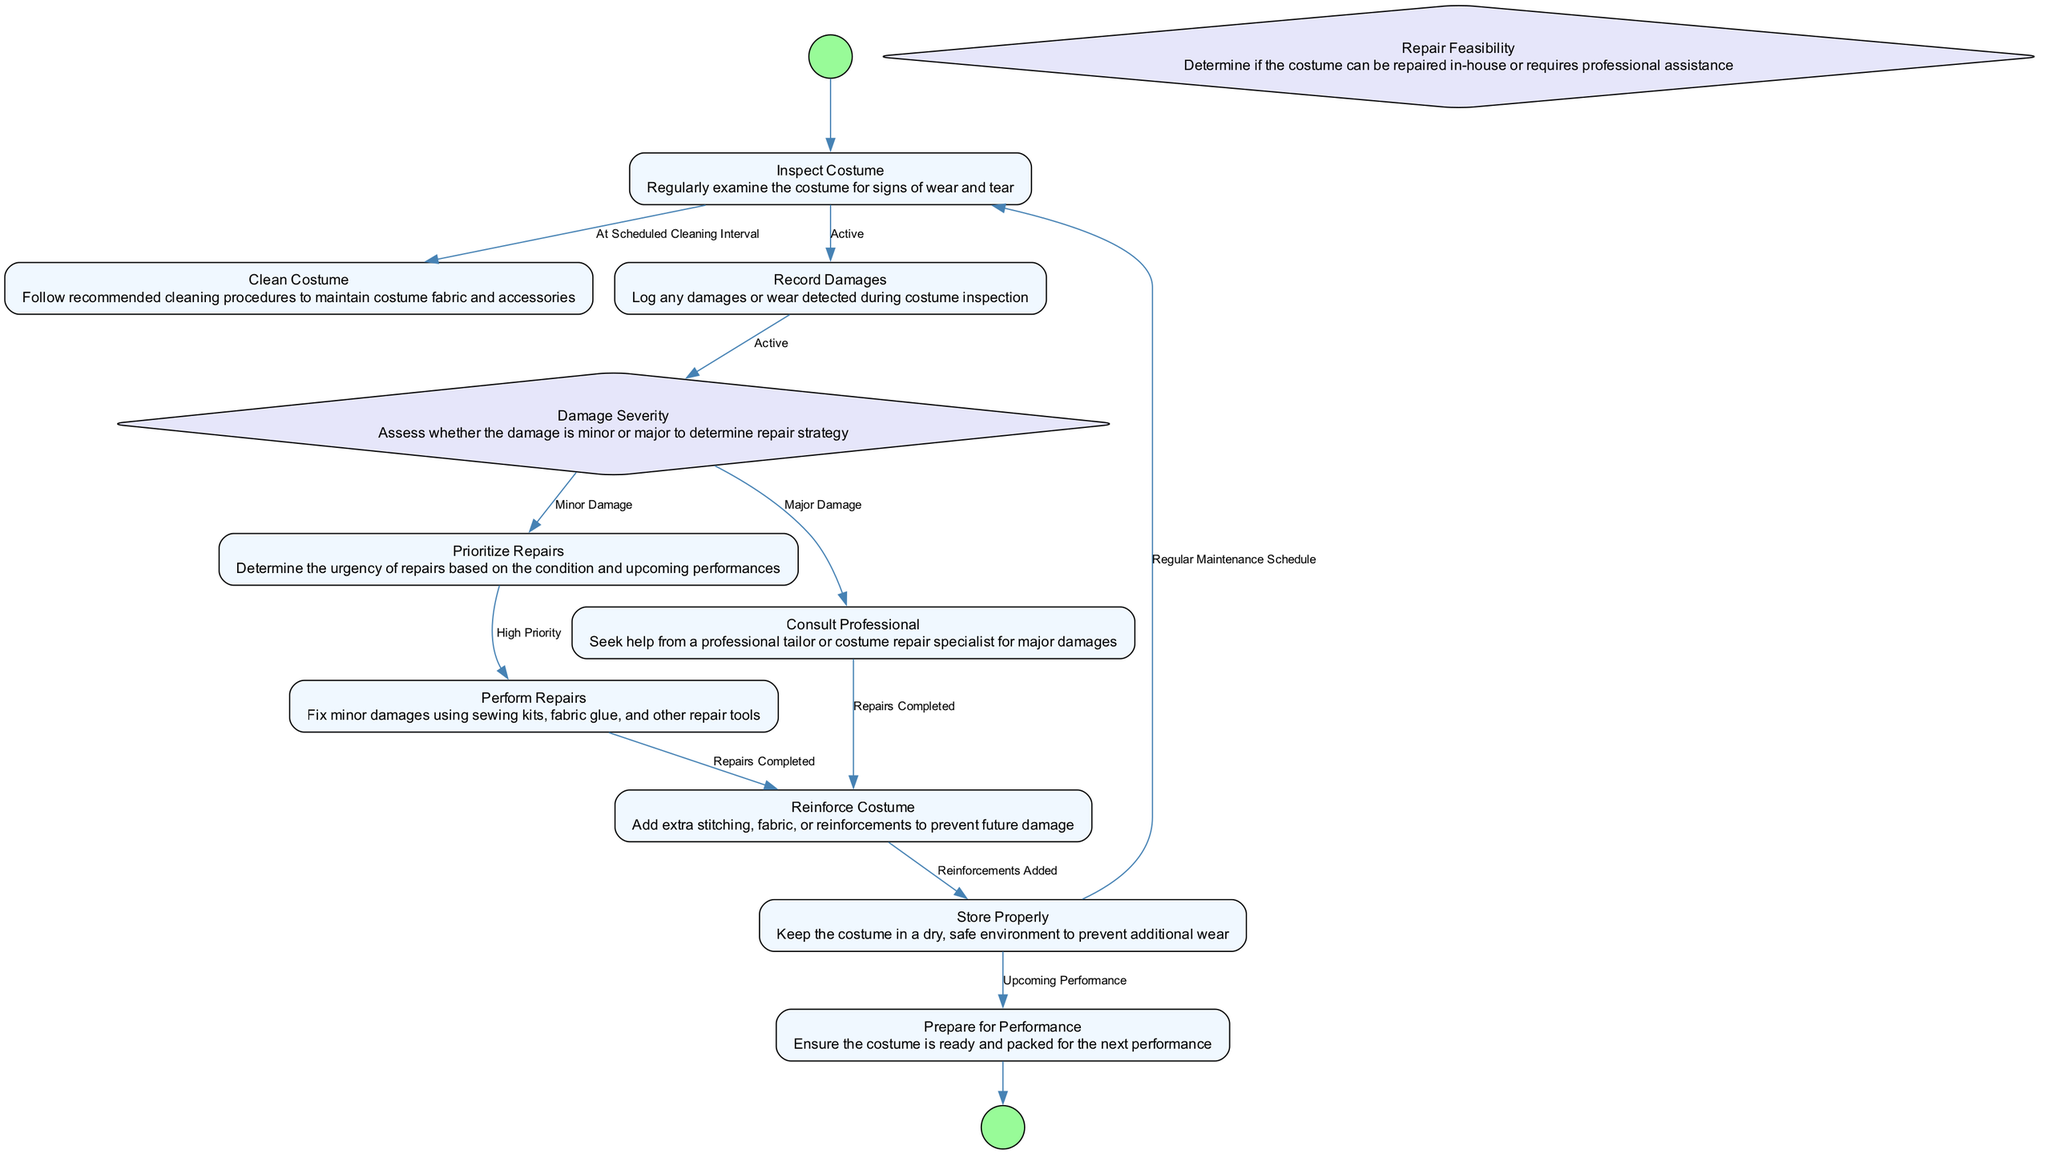What is the first action in the diagram? The first action is represented by the initial node connected to the start node, which is "Inspect Costume."
Answer: Inspect Costume How many actions are there in total? The diagram lists eight actions that are depicted as rectangular nodes. Counting all the action nodes gives a total of eight.
Answer: 8 What is the condition that leads from "Record Damages" to "Damage Severity"? The diagram shows an edge from "Record Damages" to "Damage Severity" that is labeled with the condition "Active." This indicates that the transition occurs when there are active records of damages.
Answer: Active What happens if the damage is classified as "Major Damage"? Following the decision node "Damage Severity" leads to "Consult Professional" for major damage, which indicates that action is required from a professional for repairs.
Answer: Consult Professional What action is performed after "Perform Repairs" if the repairs are completed? Once the repairs are completed, the flow goes to the next action, which is "Reinforce Costume." This indicates that reinforcement actions follow the completion of repairs.
Answer: Reinforce Costume How is "Store Properly" connected to both "Inspect Costume" and "Prepare for Performance"? "Store Properly" has two outgoing edges, one leading back to "Inspect Costume" based on a regular maintenance schedule, and another directed to "Prepare for Performance" for upcoming performances, indicating its dual role.
Answer: Regular Maintenance Schedule, Upcoming Performance What determines whether to "Perform Repairs" or to "Consult Professional"? The decision node "Damage Severity" influences the flow: if evaluated as minor damage, the next step is "Prioritize Repairs," leading to "Perform Repairs"; if major damage, the transition goes to "Consult Professional."
Answer: Damage Severity In total, how many decisions are depicted in the diagram? There are two decision nodes illustrated in the diagram, which are "Damage Severity" and "Repair Feasibility." Counting these gives a total of two.
Answer: 2 